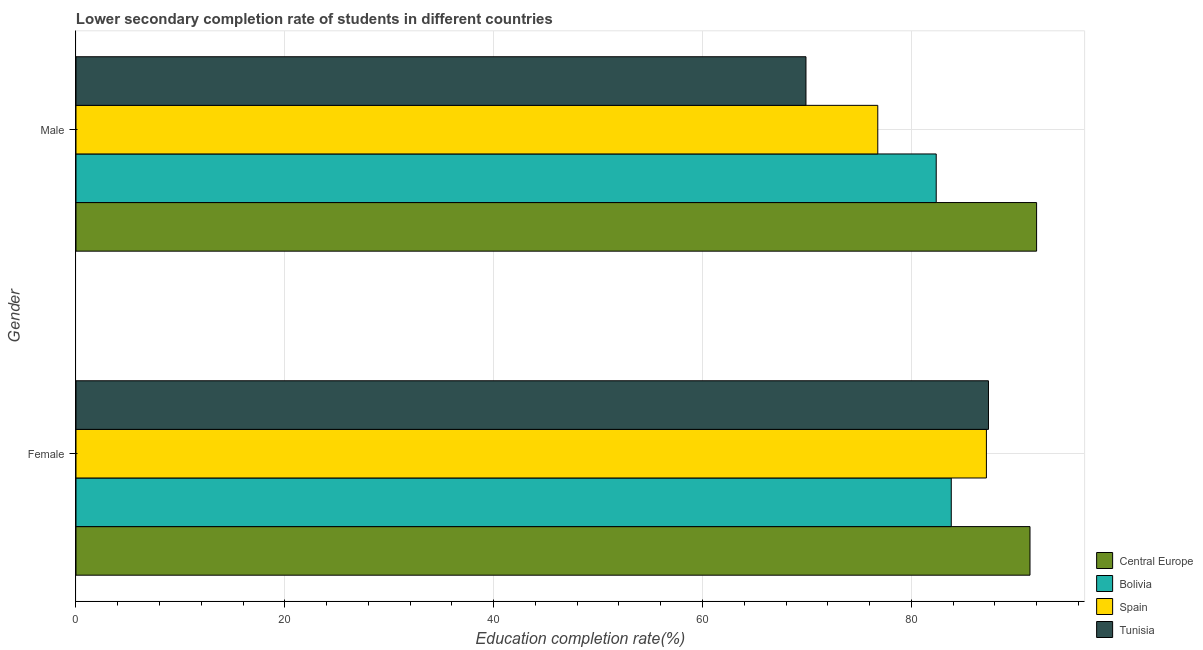How many groups of bars are there?
Provide a succinct answer. 2. Are the number of bars per tick equal to the number of legend labels?
Provide a succinct answer. Yes. How many bars are there on the 2nd tick from the bottom?
Keep it short and to the point. 4. What is the label of the 1st group of bars from the top?
Ensure brevity in your answer.  Male. What is the education completion rate of male students in Central Europe?
Your response must be concise. 91.99. Across all countries, what is the maximum education completion rate of female students?
Keep it short and to the point. 91.36. Across all countries, what is the minimum education completion rate of female students?
Offer a very short reply. 83.82. In which country was the education completion rate of male students maximum?
Your response must be concise. Central Europe. In which country was the education completion rate of female students minimum?
Offer a very short reply. Bolivia. What is the total education completion rate of male students in the graph?
Offer a terse response. 321.07. What is the difference between the education completion rate of female students in Tunisia and that in Central Europe?
Ensure brevity in your answer.  -3.98. What is the difference between the education completion rate of male students in Bolivia and the education completion rate of female students in Central Europe?
Provide a succinct answer. -8.98. What is the average education completion rate of male students per country?
Provide a succinct answer. 80.27. What is the difference between the education completion rate of female students and education completion rate of male students in Central Europe?
Your answer should be compact. -0.63. In how many countries, is the education completion rate of female students greater than 72 %?
Offer a very short reply. 4. What is the ratio of the education completion rate of male students in Bolivia to that in Spain?
Offer a very short reply. 1.07. Is the education completion rate of female students in Central Europe less than that in Bolivia?
Your response must be concise. No. In how many countries, is the education completion rate of male students greater than the average education completion rate of male students taken over all countries?
Your response must be concise. 2. What does the 1st bar from the top in Female represents?
Keep it short and to the point. Tunisia. What does the 4th bar from the bottom in Female represents?
Offer a terse response. Tunisia. Are all the bars in the graph horizontal?
Offer a very short reply. Yes. How many countries are there in the graph?
Provide a succinct answer. 4. Does the graph contain any zero values?
Your response must be concise. No. Where does the legend appear in the graph?
Offer a very short reply. Bottom right. What is the title of the graph?
Give a very brief answer. Lower secondary completion rate of students in different countries. Does "Guinea-Bissau" appear as one of the legend labels in the graph?
Offer a very short reply. No. What is the label or title of the X-axis?
Your response must be concise. Education completion rate(%). What is the label or title of the Y-axis?
Your response must be concise. Gender. What is the Education completion rate(%) of Central Europe in Female?
Your response must be concise. 91.36. What is the Education completion rate(%) of Bolivia in Female?
Give a very brief answer. 83.82. What is the Education completion rate(%) in Spain in Female?
Keep it short and to the point. 87.19. What is the Education completion rate(%) of Tunisia in Female?
Keep it short and to the point. 87.39. What is the Education completion rate(%) of Central Europe in Male?
Your response must be concise. 91.99. What is the Education completion rate(%) of Bolivia in Male?
Offer a very short reply. 82.38. What is the Education completion rate(%) of Spain in Male?
Keep it short and to the point. 76.78. What is the Education completion rate(%) in Tunisia in Male?
Your response must be concise. 69.91. Across all Gender, what is the maximum Education completion rate(%) in Central Europe?
Your answer should be compact. 91.99. Across all Gender, what is the maximum Education completion rate(%) in Bolivia?
Provide a succinct answer. 83.82. Across all Gender, what is the maximum Education completion rate(%) of Spain?
Make the answer very short. 87.19. Across all Gender, what is the maximum Education completion rate(%) in Tunisia?
Your answer should be compact. 87.39. Across all Gender, what is the minimum Education completion rate(%) in Central Europe?
Give a very brief answer. 91.36. Across all Gender, what is the minimum Education completion rate(%) of Bolivia?
Your answer should be very brief. 82.38. Across all Gender, what is the minimum Education completion rate(%) in Spain?
Your answer should be compact. 76.78. Across all Gender, what is the minimum Education completion rate(%) in Tunisia?
Provide a succinct answer. 69.91. What is the total Education completion rate(%) of Central Europe in the graph?
Provide a succinct answer. 183.36. What is the total Education completion rate(%) in Bolivia in the graph?
Your answer should be compact. 166.2. What is the total Education completion rate(%) in Spain in the graph?
Keep it short and to the point. 163.97. What is the total Education completion rate(%) in Tunisia in the graph?
Provide a succinct answer. 157.29. What is the difference between the Education completion rate(%) of Central Europe in Female and that in Male?
Provide a succinct answer. -0.63. What is the difference between the Education completion rate(%) in Bolivia in Female and that in Male?
Your answer should be compact. 1.44. What is the difference between the Education completion rate(%) of Spain in Female and that in Male?
Keep it short and to the point. 10.4. What is the difference between the Education completion rate(%) in Tunisia in Female and that in Male?
Offer a very short reply. 17.48. What is the difference between the Education completion rate(%) in Central Europe in Female and the Education completion rate(%) in Bolivia in Male?
Make the answer very short. 8.98. What is the difference between the Education completion rate(%) in Central Europe in Female and the Education completion rate(%) in Spain in Male?
Your answer should be compact. 14.58. What is the difference between the Education completion rate(%) of Central Europe in Female and the Education completion rate(%) of Tunisia in Male?
Provide a short and direct response. 21.45. What is the difference between the Education completion rate(%) in Bolivia in Female and the Education completion rate(%) in Spain in Male?
Your answer should be compact. 7.04. What is the difference between the Education completion rate(%) in Bolivia in Female and the Education completion rate(%) in Tunisia in Male?
Provide a succinct answer. 13.92. What is the difference between the Education completion rate(%) of Spain in Female and the Education completion rate(%) of Tunisia in Male?
Your answer should be compact. 17.28. What is the average Education completion rate(%) of Central Europe per Gender?
Keep it short and to the point. 91.68. What is the average Education completion rate(%) of Bolivia per Gender?
Your response must be concise. 83.1. What is the average Education completion rate(%) in Spain per Gender?
Your answer should be compact. 81.99. What is the average Education completion rate(%) of Tunisia per Gender?
Provide a succinct answer. 78.65. What is the difference between the Education completion rate(%) in Central Europe and Education completion rate(%) in Bolivia in Female?
Offer a very short reply. 7.54. What is the difference between the Education completion rate(%) of Central Europe and Education completion rate(%) of Spain in Female?
Provide a succinct answer. 4.17. What is the difference between the Education completion rate(%) in Central Europe and Education completion rate(%) in Tunisia in Female?
Provide a succinct answer. 3.98. What is the difference between the Education completion rate(%) of Bolivia and Education completion rate(%) of Spain in Female?
Your answer should be very brief. -3.36. What is the difference between the Education completion rate(%) of Bolivia and Education completion rate(%) of Tunisia in Female?
Give a very brief answer. -3.56. What is the difference between the Education completion rate(%) in Spain and Education completion rate(%) in Tunisia in Female?
Your answer should be compact. -0.2. What is the difference between the Education completion rate(%) in Central Europe and Education completion rate(%) in Bolivia in Male?
Offer a very short reply. 9.61. What is the difference between the Education completion rate(%) in Central Europe and Education completion rate(%) in Spain in Male?
Offer a terse response. 15.21. What is the difference between the Education completion rate(%) of Central Europe and Education completion rate(%) of Tunisia in Male?
Keep it short and to the point. 22.09. What is the difference between the Education completion rate(%) of Bolivia and Education completion rate(%) of Spain in Male?
Make the answer very short. 5.6. What is the difference between the Education completion rate(%) of Bolivia and Education completion rate(%) of Tunisia in Male?
Keep it short and to the point. 12.47. What is the difference between the Education completion rate(%) in Spain and Education completion rate(%) in Tunisia in Male?
Give a very brief answer. 6.88. What is the ratio of the Education completion rate(%) in Central Europe in Female to that in Male?
Your answer should be very brief. 0.99. What is the ratio of the Education completion rate(%) in Bolivia in Female to that in Male?
Offer a very short reply. 1.02. What is the ratio of the Education completion rate(%) in Spain in Female to that in Male?
Ensure brevity in your answer.  1.14. What is the difference between the highest and the second highest Education completion rate(%) in Central Europe?
Ensure brevity in your answer.  0.63. What is the difference between the highest and the second highest Education completion rate(%) of Bolivia?
Give a very brief answer. 1.44. What is the difference between the highest and the second highest Education completion rate(%) of Spain?
Provide a succinct answer. 10.4. What is the difference between the highest and the second highest Education completion rate(%) of Tunisia?
Your answer should be compact. 17.48. What is the difference between the highest and the lowest Education completion rate(%) in Central Europe?
Make the answer very short. 0.63. What is the difference between the highest and the lowest Education completion rate(%) of Bolivia?
Your answer should be compact. 1.44. What is the difference between the highest and the lowest Education completion rate(%) in Spain?
Offer a very short reply. 10.4. What is the difference between the highest and the lowest Education completion rate(%) of Tunisia?
Provide a succinct answer. 17.48. 